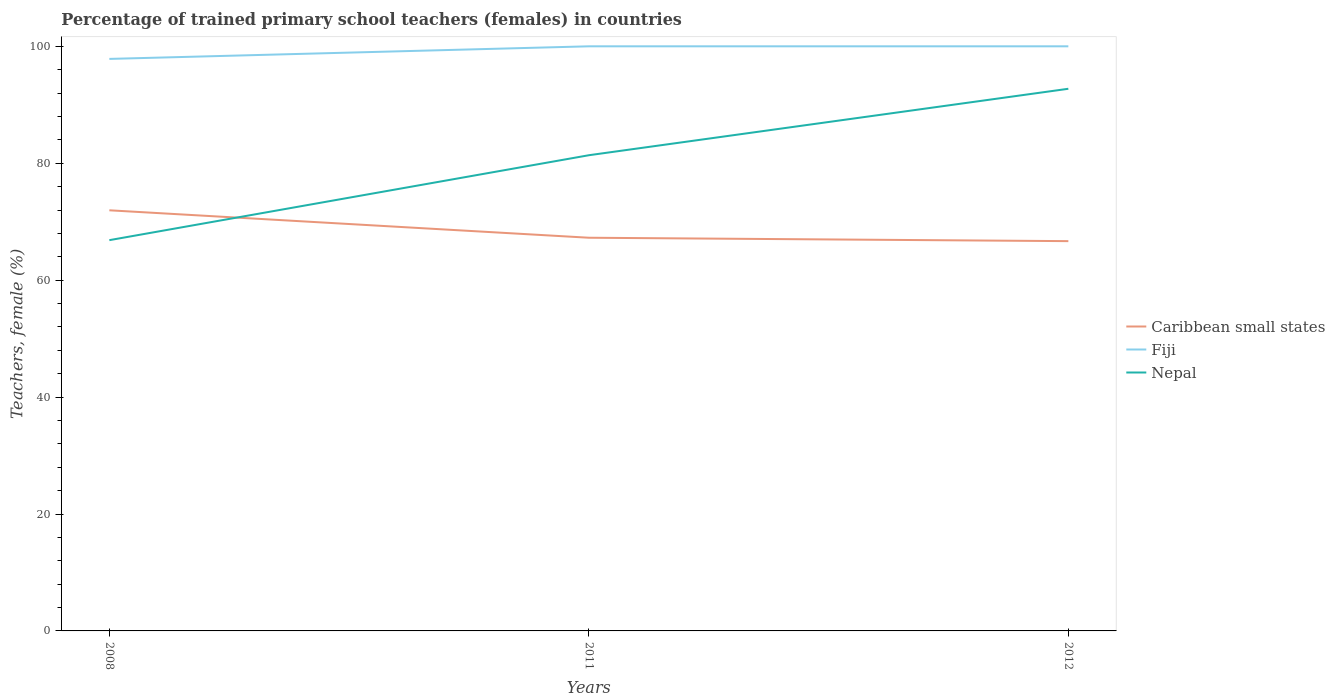Is the number of lines equal to the number of legend labels?
Your answer should be compact. Yes. Across all years, what is the maximum percentage of trained primary school teachers (females) in Nepal?
Your answer should be very brief. 66.84. What is the total percentage of trained primary school teachers (females) in Fiji in the graph?
Offer a very short reply. -2.15. What is the difference between the highest and the second highest percentage of trained primary school teachers (females) in Fiji?
Keep it short and to the point. 2.15. What is the difference between the highest and the lowest percentage of trained primary school teachers (females) in Caribbean small states?
Your response must be concise. 1. Is the percentage of trained primary school teachers (females) in Caribbean small states strictly greater than the percentage of trained primary school teachers (females) in Nepal over the years?
Make the answer very short. No. How many lines are there?
Your answer should be very brief. 3. How many years are there in the graph?
Keep it short and to the point. 3. Are the values on the major ticks of Y-axis written in scientific E-notation?
Make the answer very short. No. Does the graph contain any zero values?
Ensure brevity in your answer.  No. Does the graph contain grids?
Make the answer very short. No. How many legend labels are there?
Provide a succinct answer. 3. How are the legend labels stacked?
Provide a short and direct response. Vertical. What is the title of the graph?
Offer a terse response. Percentage of trained primary school teachers (females) in countries. What is the label or title of the X-axis?
Give a very brief answer. Years. What is the label or title of the Y-axis?
Offer a very short reply. Teachers, female (%). What is the Teachers, female (%) in Caribbean small states in 2008?
Offer a very short reply. 71.95. What is the Teachers, female (%) in Fiji in 2008?
Give a very brief answer. 97.85. What is the Teachers, female (%) in Nepal in 2008?
Your response must be concise. 66.84. What is the Teachers, female (%) of Caribbean small states in 2011?
Ensure brevity in your answer.  67.26. What is the Teachers, female (%) in Nepal in 2011?
Your answer should be compact. 81.37. What is the Teachers, female (%) of Caribbean small states in 2012?
Your answer should be very brief. 66.67. What is the Teachers, female (%) of Fiji in 2012?
Offer a very short reply. 100. What is the Teachers, female (%) in Nepal in 2012?
Offer a terse response. 92.74. Across all years, what is the maximum Teachers, female (%) of Caribbean small states?
Make the answer very short. 71.95. Across all years, what is the maximum Teachers, female (%) in Fiji?
Provide a short and direct response. 100. Across all years, what is the maximum Teachers, female (%) of Nepal?
Your answer should be compact. 92.74. Across all years, what is the minimum Teachers, female (%) in Caribbean small states?
Make the answer very short. 66.67. Across all years, what is the minimum Teachers, female (%) of Fiji?
Make the answer very short. 97.85. Across all years, what is the minimum Teachers, female (%) of Nepal?
Your answer should be compact. 66.84. What is the total Teachers, female (%) of Caribbean small states in the graph?
Your response must be concise. 205.88. What is the total Teachers, female (%) in Fiji in the graph?
Offer a terse response. 297.85. What is the total Teachers, female (%) in Nepal in the graph?
Your response must be concise. 240.95. What is the difference between the Teachers, female (%) of Caribbean small states in 2008 and that in 2011?
Give a very brief answer. 4.69. What is the difference between the Teachers, female (%) of Fiji in 2008 and that in 2011?
Give a very brief answer. -2.15. What is the difference between the Teachers, female (%) of Nepal in 2008 and that in 2011?
Offer a very short reply. -14.53. What is the difference between the Teachers, female (%) of Caribbean small states in 2008 and that in 2012?
Provide a succinct answer. 5.28. What is the difference between the Teachers, female (%) of Fiji in 2008 and that in 2012?
Keep it short and to the point. -2.15. What is the difference between the Teachers, female (%) of Nepal in 2008 and that in 2012?
Make the answer very short. -25.9. What is the difference between the Teachers, female (%) in Caribbean small states in 2011 and that in 2012?
Make the answer very short. 0.58. What is the difference between the Teachers, female (%) in Fiji in 2011 and that in 2012?
Your answer should be very brief. 0. What is the difference between the Teachers, female (%) of Nepal in 2011 and that in 2012?
Offer a very short reply. -11.37. What is the difference between the Teachers, female (%) in Caribbean small states in 2008 and the Teachers, female (%) in Fiji in 2011?
Your answer should be compact. -28.05. What is the difference between the Teachers, female (%) of Caribbean small states in 2008 and the Teachers, female (%) of Nepal in 2011?
Make the answer very short. -9.42. What is the difference between the Teachers, female (%) in Fiji in 2008 and the Teachers, female (%) in Nepal in 2011?
Ensure brevity in your answer.  16.48. What is the difference between the Teachers, female (%) in Caribbean small states in 2008 and the Teachers, female (%) in Fiji in 2012?
Your answer should be very brief. -28.05. What is the difference between the Teachers, female (%) in Caribbean small states in 2008 and the Teachers, female (%) in Nepal in 2012?
Ensure brevity in your answer.  -20.79. What is the difference between the Teachers, female (%) of Fiji in 2008 and the Teachers, female (%) of Nepal in 2012?
Keep it short and to the point. 5.11. What is the difference between the Teachers, female (%) in Caribbean small states in 2011 and the Teachers, female (%) in Fiji in 2012?
Your response must be concise. -32.74. What is the difference between the Teachers, female (%) in Caribbean small states in 2011 and the Teachers, female (%) in Nepal in 2012?
Offer a terse response. -25.48. What is the difference between the Teachers, female (%) of Fiji in 2011 and the Teachers, female (%) of Nepal in 2012?
Your answer should be very brief. 7.26. What is the average Teachers, female (%) of Caribbean small states per year?
Provide a short and direct response. 68.63. What is the average Teachers, female (%) of Fiji per year?
Offer a terse response. 99.28. What is the average Teachers, female (%) of Nepal per year?
Your response must be concise. 80.32. In the year 2008, what is the difference between the Teachers, female (%) of Caribbean small states and Teachers, female (%) of Fiji?
Offer a very short reply. -25.9. In the year 2008, what is the difference between the Teachers, female (%) in Caribbean small states and Teachers, female (%) in Nepal?
Offer a terse response. 5.11. In the year 2008, what is the difference between the Teachers, female (%) in Fiji and Teachers, female (%) in Nepal?
Provide a succinct answer. 31. In the year 2011, what is the difference between the Teachers, female (%) of Caribbean small states and Teachers, female (%) of Fiji?
Ensure brevity in your answer.  -32.74. In the year 2011, what is the difference between the Teachers, female (%) of Caribbean small states and Teachers, female (%) of Nepal?
Provide a short and direct response. -14.11. In the year 2011, what is the difference between the Teachers, female (%) in Fiji and Teachers, female (%) in Nepal?
Your answer should be very brief. 18.63. In the year 2012, what is the difference between the Teachers, female (%) in Caribbean small states and Teachers, female (%) in Fiji?
Offer a very short reply. -33.33. In the year 2012, what is the difference between the Teachers, female (%) in Caribbean small states and Teachers, female (%) in Nepal?
Give a very brief answer. -26.06. In the year 2012, what is the difference between the Teachers, female (%) in Fiji and Teachers, female (%) in Nepal?
Give a very brief answer. 7.26. What is the ratio of the Teachers, female (%) in Caribbean small states in 2008 to that in 2011?
Your answer should be compact. 1.07. What is the ratio of the Teachers, female (%) of Fiji in 2008 to that in 2011?
Give a very brief answer. 0.98. What is the ratio of the Teachers, female (%) of Nepal in 2008 to that in 2011?
Your response must be concise. 0.82. What is the ratio of the Teachers, female (%) in Caribbean small states in 2008 to that in 2012?
Your answer should be compact. 1.08. What is the ratio of the Teachers, female (%) in Fiji in 2008 to that in 2012?
Your response must be concise. 0.98. What is the ratio of the Teachers, female (%) of Nepal in 2008 to that in 2012?
Offer a very short reply. 0.72. What is the ratio of the Teachers, female (%) of Caribbean small states in 2011 to that in 2012?
Your response must be concise. 1.01. What is the ratio of the Teachers, female (%) in Nepal in 2011 to that in 2012?
Provide a succinct answer. 0.88. What is the difference between the highest and the second highest Teachers, female (%) in Caribbean small states?
Offer a very short reply. 4.69. What is the difference between the highest and the second highest Teachers, female (%) in Fiji?
Your answer should be compact. 0. What is the difference between the highest and the second highest Teachers, female (%) in Nepal?
Keep it short and to the point. 11.37. What is the difference between the highest and the lowest Teachers, female (%) in Caribbean small states?
Give a very brief answer. 5.28. What is the difference between the highest and the lowest Teachers, female (%) in Fiji?
Keep it short and to the point. 2.15. What is the difference between the highest and the lowest Teachers, female (%) in Nepal?
Provide a succinct answer. 25.9. 